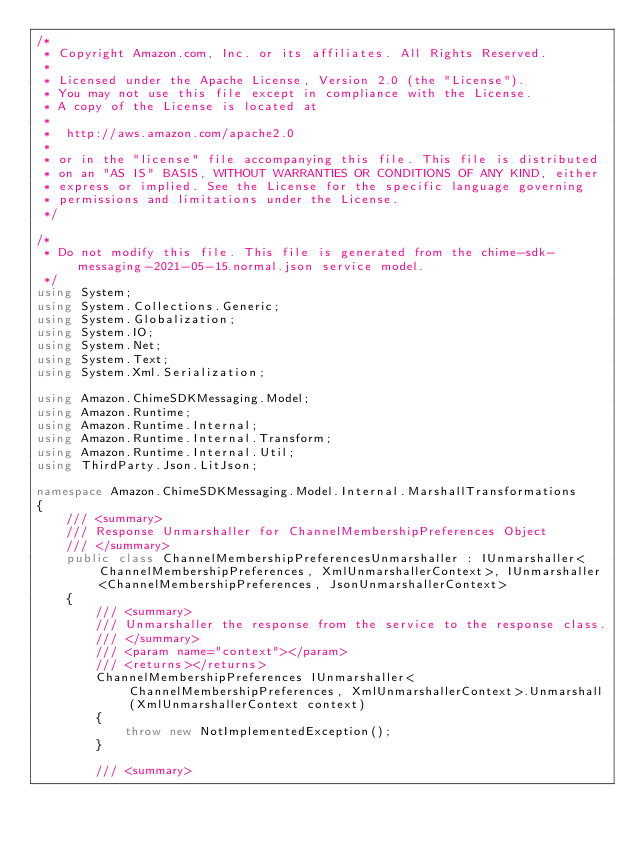<code> <loc_0><loc_0><loc_500><loc_500><_C#_>/*
 * Copyright Amazon.com, Inc. or its affiliates. All Rights Reserved.
 * 
 * Licensed under the Apache License, Version 2.0 (the "License").
 * You may not use this file except in compliance with the License.
 * A copy of the License is located at
 * 
 *  http://aws.amazon.com/apache2.0
 * 
 * or in the "license" file accompanying this file. This file is distributed
 * on an "AS IS" BASIS, WITHOUT WARRANTIES OR CONDITIONS OF ANY KIND, either
 * express or implied. See the License for the specific language governing
 * permissions and limitations under the License.
 */

/*
 * Do not modify this file. This file is generated from the chime-sdk-messaging-2021-05-15.normal.json service model.
 */
using System;
using System.Collections.Generic;
using System.Globalization;
using System.IO;
using System.Net;
using System.Text;
using System.Xml.Serialization;

using Amazon.ChimeSDKMessaging.Model;
using Amazon.Runtime;
using Amazon.Runtime.Internal;
using Amazon.Runtime.Internal.Transform;
using Amazon.Runtime.Internal.Util;
using ThirdParty.Json.LitJson;

namespace Amazon.ChimeSDKMessaging.Model.Internal.MarshallTransformations
{
    /// <summary>
    /// Response Unmarshaller for ChannelMembershipPreferences Object
    /// </summary>  
    public class ChannelMembershipPreferencesUnmarshaller : IUnmarshaller<ChannelMembershipPreferences, XmlUnmarshallerContext>, IUnmarshaller<ChannelMembershipPreferences, JsonUnmarshallerContext>
    {
        /// <summary>
        /// Unmarshaller the response from the service to the response class.
        /// </summary>  
        /// <param name="context"></param>
        /// <returns></returns>
        ChannelMembershipPreferences IUnmarshaller<ChannelMembershipPreferences, XmlUnmarshallerContext>.Unmarshall(XmlUnmarshallerContext context)
        {
            throw new NotImplementedException();
        }

        /// <summary></code> 